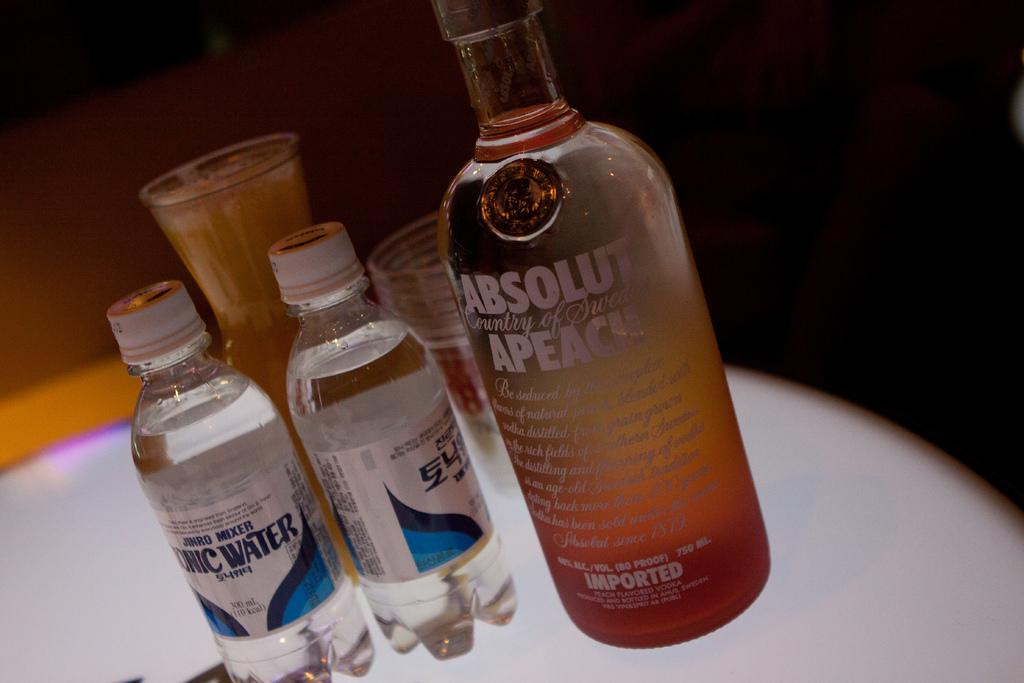<image>
Present a compact description of the photo's key features. Bottle of Absolut Apeach next to two small clear bottles. 